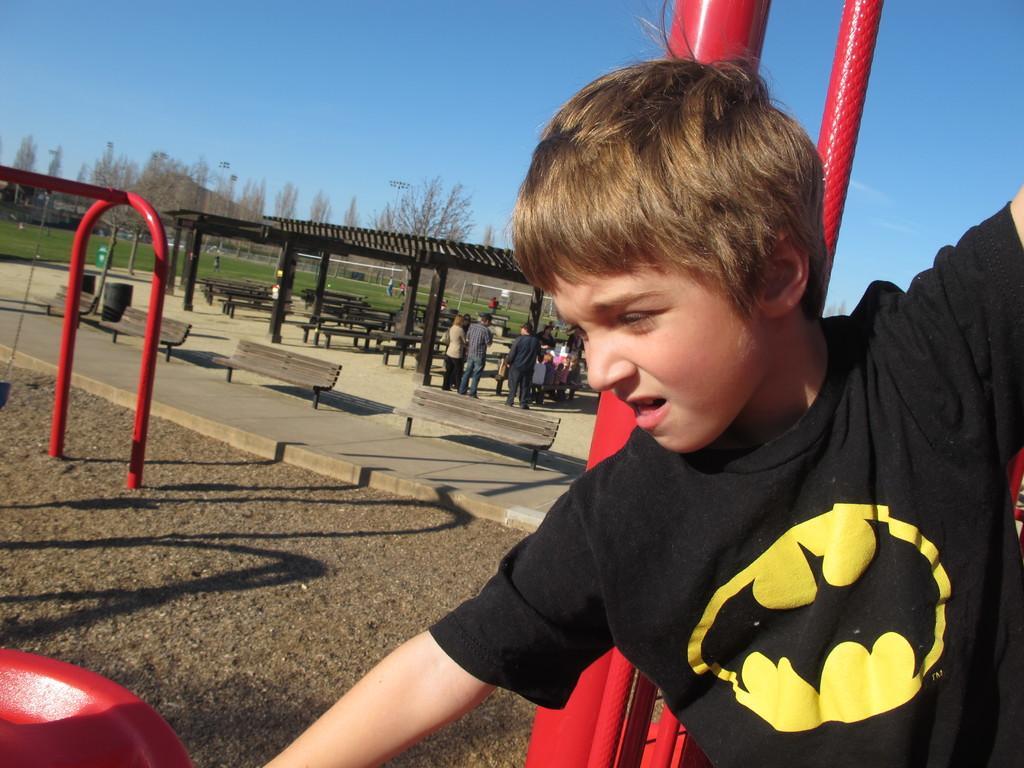Describe this image in one or two sentences. In this picture I can see few trees and few people standing and I can see benches and I can see a boy and I can see grass on the ground and a blue sky and I can see few metal rods. 